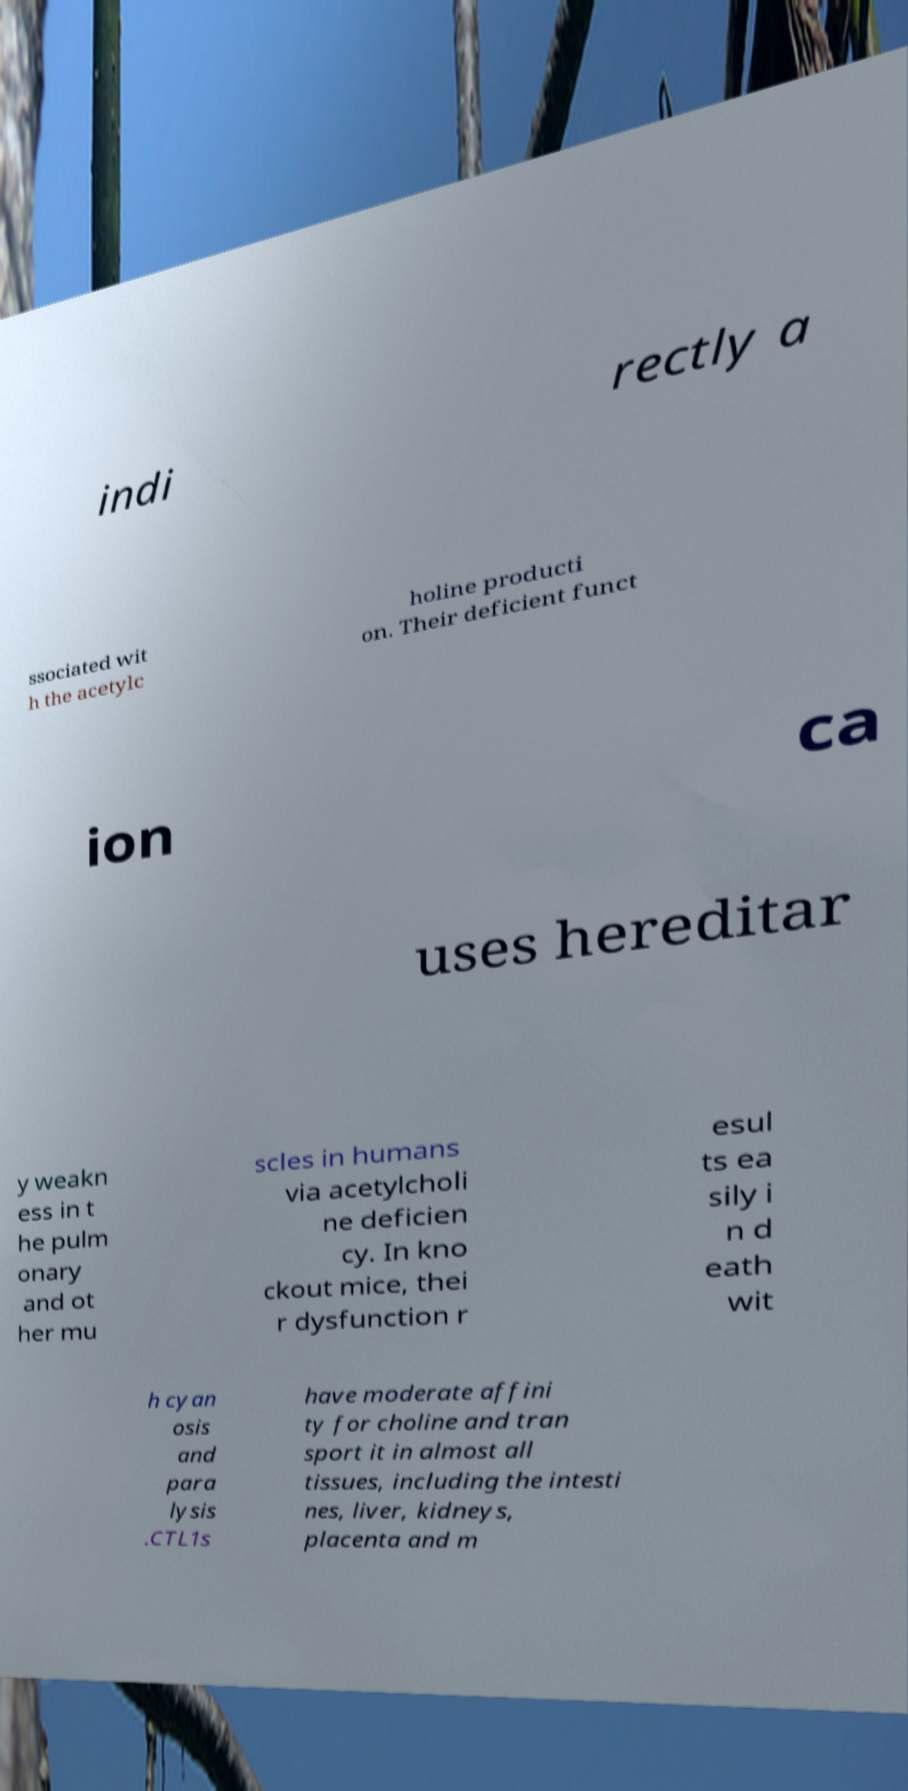Please read and relay the text visible in this image. What does it say? indi rectly a ssociated wit h the acetylc holine producti on. Their deficient funct ion ca uses hereditar y weakn ess in t he pulm onary and ot her mu scles in humans via acetylcholi ne deficien cy. In kno ckout mice, thei r dysfunction r esul ts ea sily i n d eath wit h cyan osis and para lysis .CTL1s have moderate affini ty for choline and tran sport it in almost all tissues, including the intesti nes, liver, kidneys, placenta and m 